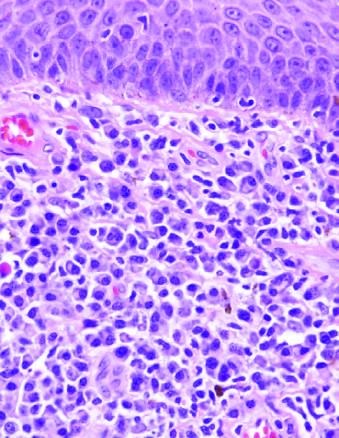what do histologic features of the chancre include beneath squamous epithelium of skin?
Answer the question using a single word or phrase. A diffuse plasma cell infiltrate 